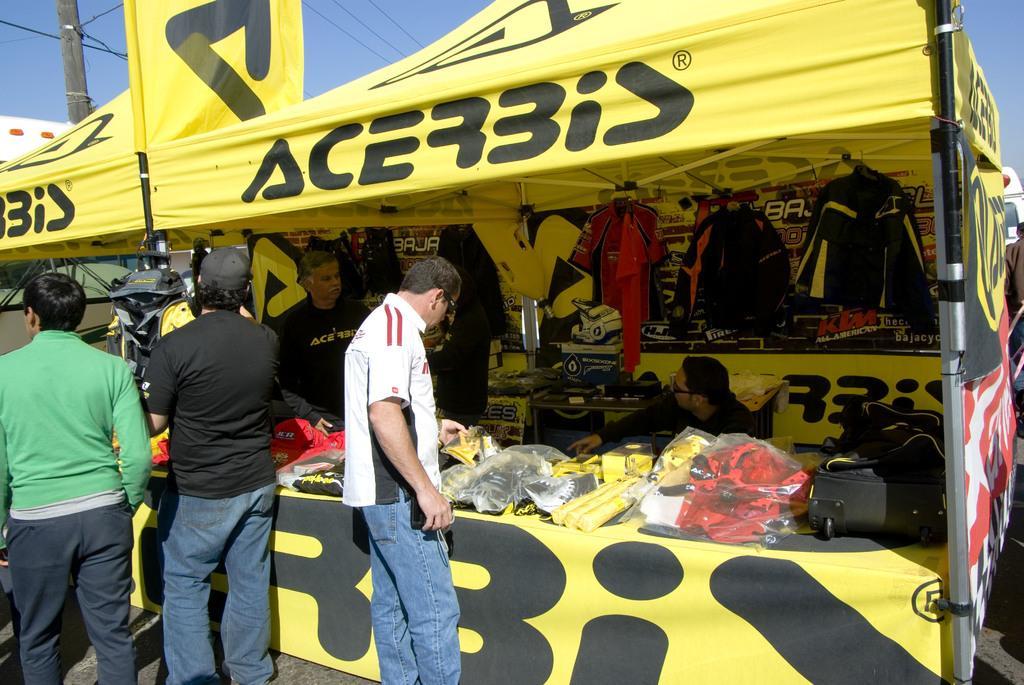Please provide a concise description of this image. This picture is clicked outside. On the left we can see the group of persons wearing t-shirts and standing on the ground. On the right there is a person seems to be sitting and we can see there are some items placed on the top of the table. In the background we can see the sky, pole, cables and a yellow color tent on which we can see the text and we can see the clothes are hanging on the metal rods. 